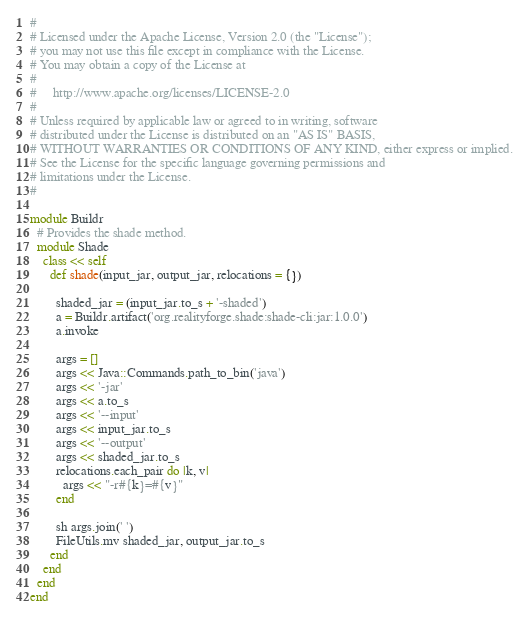Convert code to text. <code><loc_0><loc_0><loc_500><loc_500><_Ruby_>#
# Licensed under the Apache License, Version 2.0 (the "License");
# you may not use this file except in compliance with the License.
# You may obtain a copy of the License at
#
#     http://www.apache.org/licenses/LICENSE-2.0
#
# Unless required by applicable law or agreed to in writing, software
# distributed under the License is distributed on an "AS IS" BASIS,
# WITHOUT WARRANTIES OR CONDITIONS OF ANY KIND, either express or implied.
# See the License for the specific language governing permissions and
# limitations under the License.
#

module Buildr
  # Provides the shade method.
  module Shade
    class << self
      def shade(input_jar, output_jar, relocations = {})

        shaded_jar = (input_jar.to_s + '-shaded')
        a = Buildr.artifact('org.realityforge.shade:shade-cli:jar:1.0.0')
        a.invoke

        args = []
        args << Java::Commands.path_to_bin('java')
        args << '-jar'
        args << a.to_s
        args << '--input'
        args << input_jar.to_s
        args << '--output'
        args << shaded_jar.to_s
        relocations.each_pair do |k, v|
          args << "-r#{k}=#{v}"
        end

        sh args.join(' ')
        FileUtils.mv shaded_jar, output_jar.to_s
      end
    end
  end
end
</code> 